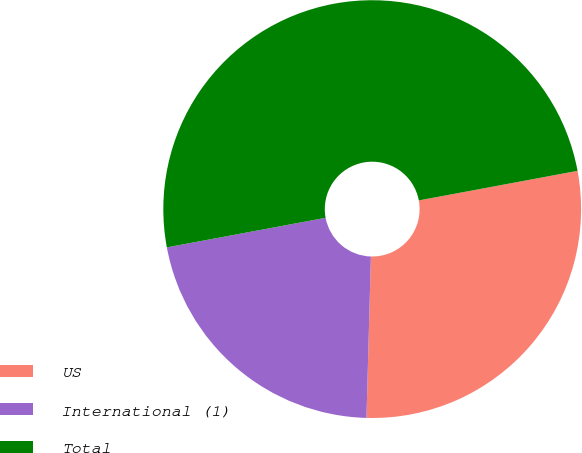Convert chart to OTSL. <chart><loc_0><loc_0><loc_500><loc_500><pie_chart><fcel>US<fcel>International (1)<fcel>Total<nl><fcel>28.37%<fcel>21.63%<fcel>50.0%<nl></chart> 